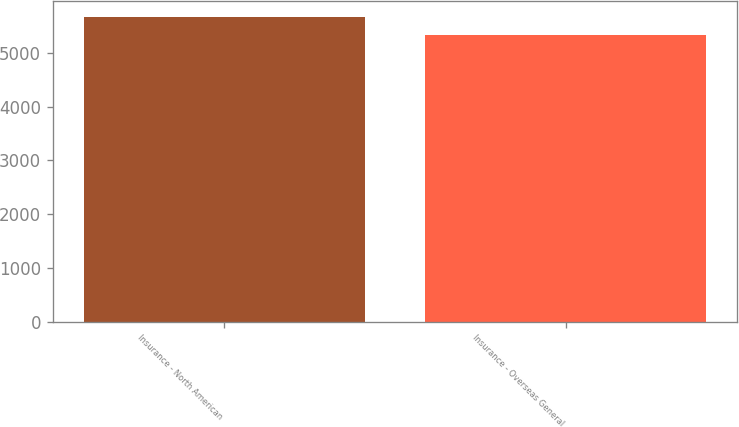Convert chart. <chart><loc_0><loc_0><loc_500><loc_500><bar_chart><fcel>Insurance - North American<fcel>Insurance - Overseas General<nl><fcel>5679<fcel>5337<nl></chart> 